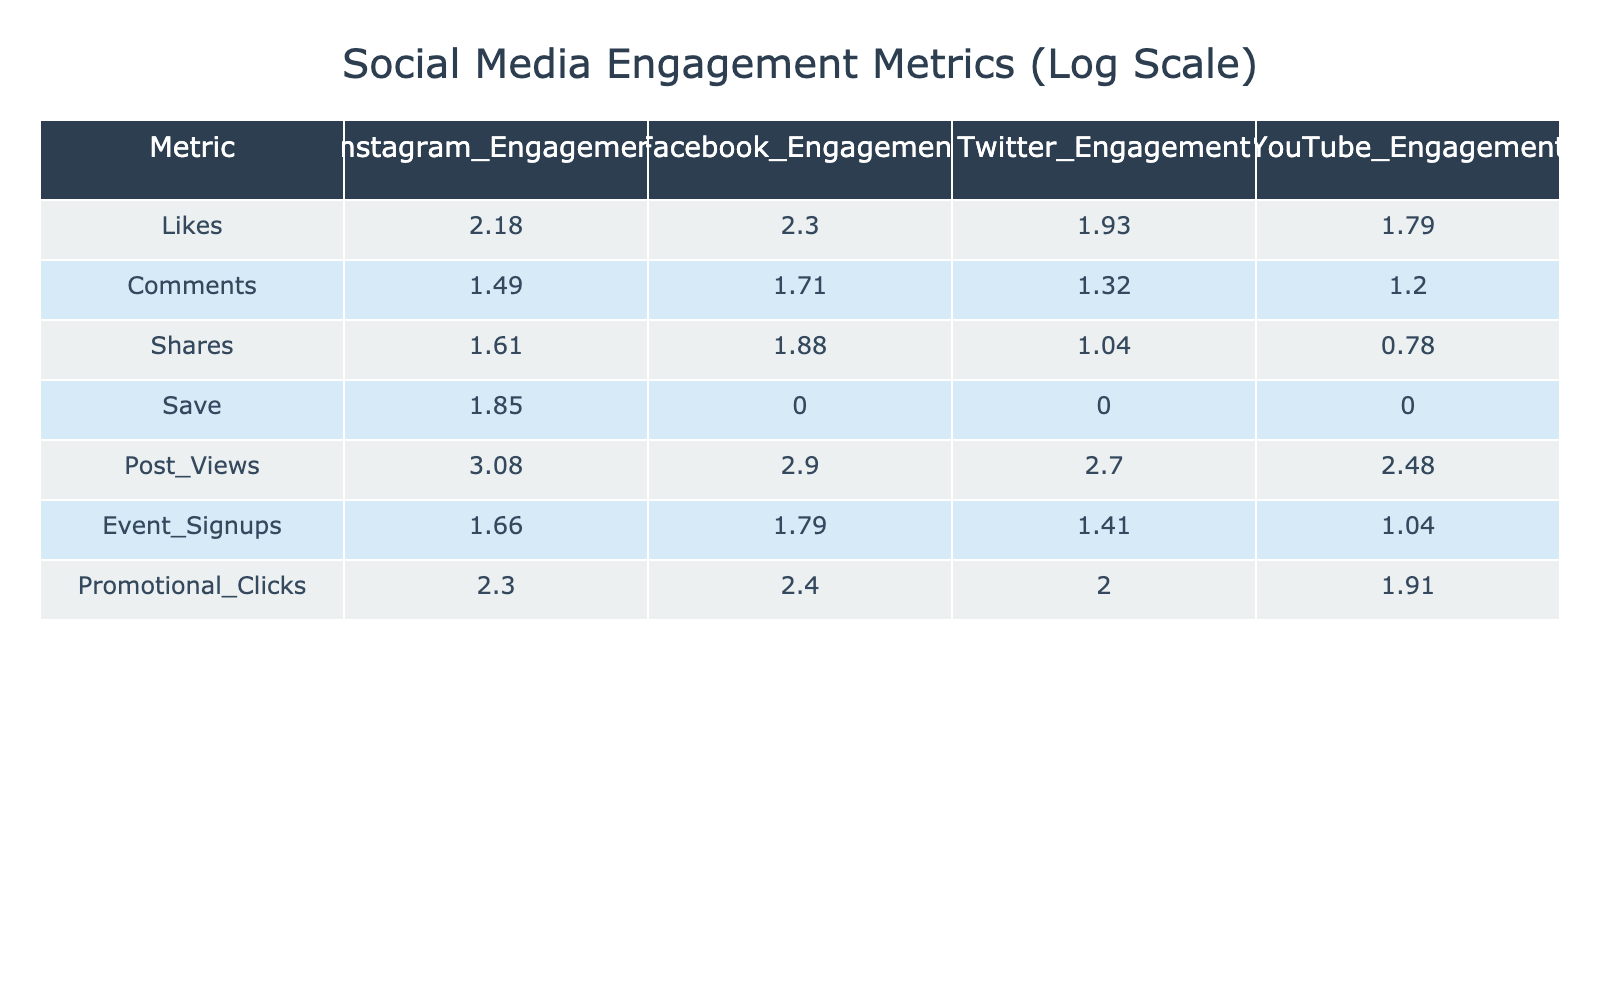What is the logarithmic value of Instagram likes? The logarithmic value of likes on Instagram is provided directly in the table. Looking at the Instagram engagement column for likes, we find the value is 2.18.
Answer: 2.18 Which platform has the highest number of shares? To determine the highest number of shares, we compare the share values across all platforms. The shares for Instagram is 1.61, for Facebook is 1.88, for Twitter is 1.00, and for YouTube is 0.70. The highest number of shares is for Facebook.
Answer: Facebook What is the total number of promotional clicks across all platforms? To find the total promotional clicks, we sum the values from each platform: Instagram (2.30) + Facebook (2.40) + Twitter (2.00) + YouTube (1.90) = 8.60.
Answer: 8.60 Is it true that YouTube has any saves recorded? Checking the saves for YouTube in the table, the value is 0. This confirms that YouTube has no saves recorded.
Answer: No How many more comments does Facebook have compared to Twitter? We take the number of comments on Facebook (1.70) and subtract the number of comments on Twitter (1.30): 1.70 - 1.30 = 0.40, indicating that Facebook has 0.40 more comments than Twitter.
Answer: 0.40 What is the average event signups across the four platforms? To find the average event signups, we sum the values and divide by the number of platforms: (1.65 + 1.78 + 1.40 + 1.00) = 5.83. Dividing by 4 gives us 1.46.
Answer: 1.46 Which platform has the least post views? By comparing the post views across all platforms, we see Instagram has 3.08, Facebook has 2.90, Twitter has 2.70, and YouTube has 2.48. The least post views are for YouTube.
Answer: YouTube What is the difference in likes between Instagram and Facebook? The likes for Instagram is 2.18, and Facebook is 2.30. To find the difference: 2.30 - 2.18 = 0.12. Therefore, Facebook has 0.12 more likes than Instagram.
Answer: 0.12 How many shares does Twitter have? The number of shares on Twitter is listed in the table, which shows the value is 1.00.
Answer: 1.00 